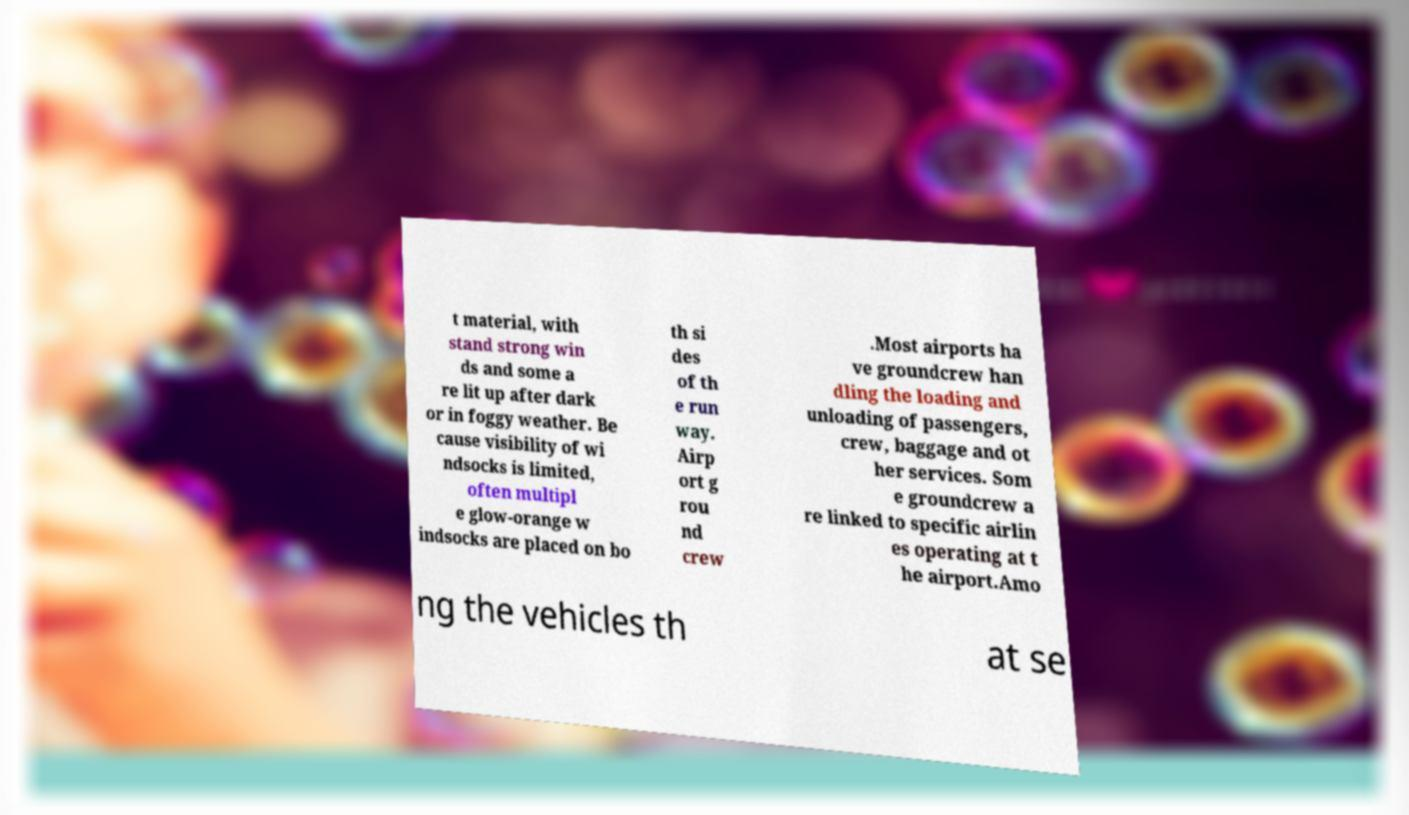I need the written content from this picture converted into text. Can you do that? t material, with stand strong win ds and some a re lit up after dark or in foggy weather. Be cause visibility of wi ndsocks is limited, often multipl e glow-orange w indsocks are placed on bo th si des of th e run way. Airp ort g rou nd crew .Most airports ha ve groundcrew han dling the loading and unloading of passengers, crew, baggage and ot her services. Som e groundcrew a re linked to specific airlin es operating at t he airport.Amo ng the vehicles th at se 